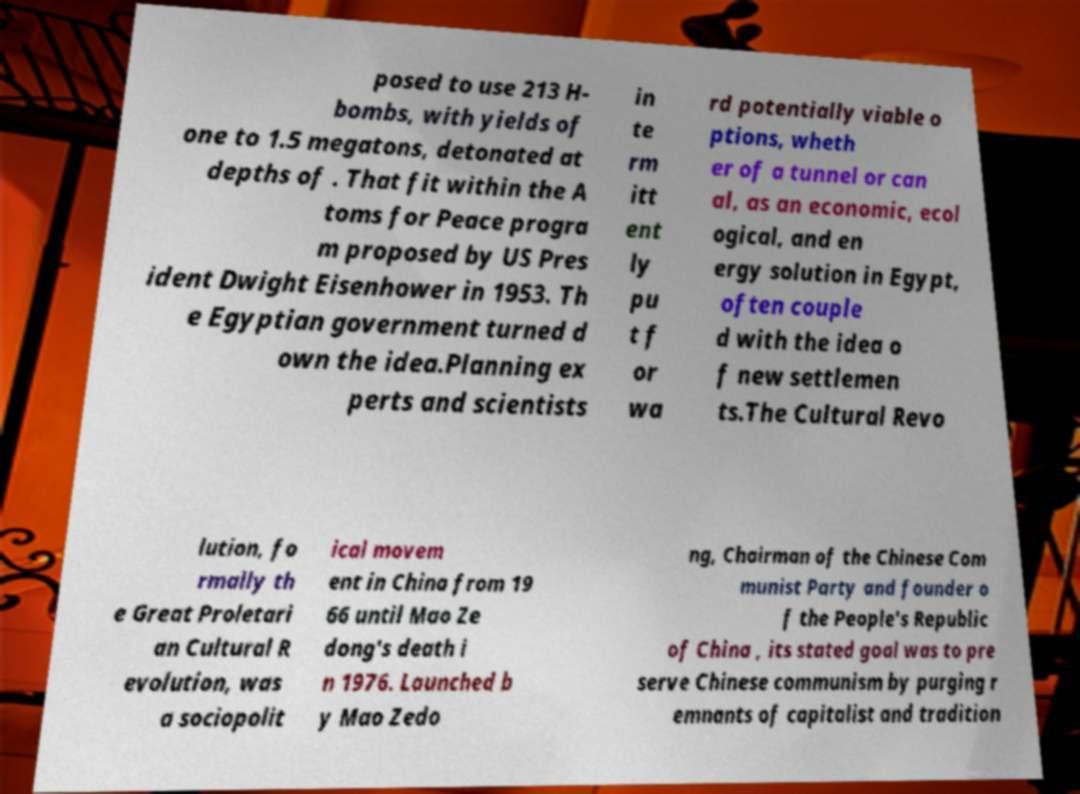Could you extract and type out the text from this image? posed to use 213 H- bombs, with yields of one to 1.5 megatons, detonated at depths of . That fit within the A toms for Peace progra m proposed by US Pres ident Dwight Eisenhower in 1953. Th e Egyptian government turned d own the idea.Planning ex perts and scientists in te rm itt ent ly pu t f or wa rd potentially viable o ptions, wheth er of a tunnel or can al, as an economic, ecol ogical, and en ergy solution in Egypt, often couple d with the idea o f new settlemen ts.The Cultural Revo lution, fo rmally th e Great Proletari an Cultural R evolution, was a sociopolit ical movem ent in China from 19 66 until Mao Ze dong's death i n 1976. Launched b y Mao Zedo ng, Chairman of the Chinese Com munist Party and founder o f the People's Republic of China , its stated goal was to pre serve Chinese communism by purging r emnants of capitalist and tradition 